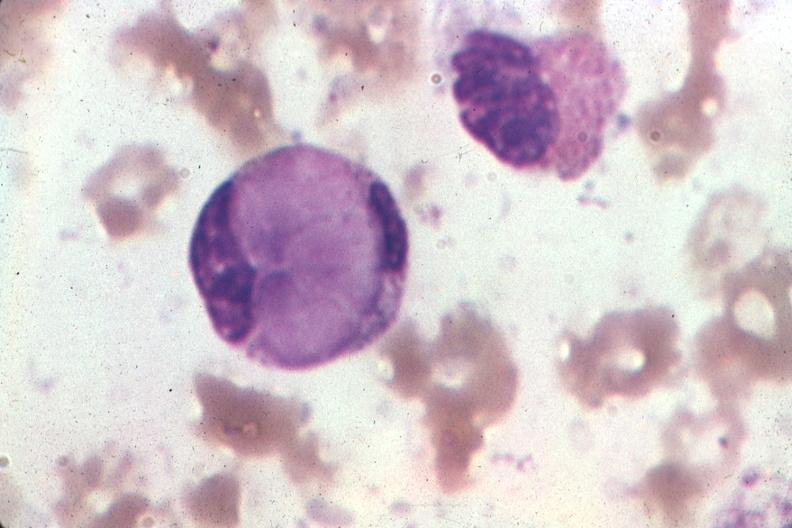what is present?
Answer the question using a single word or phrase. Bone marrow 